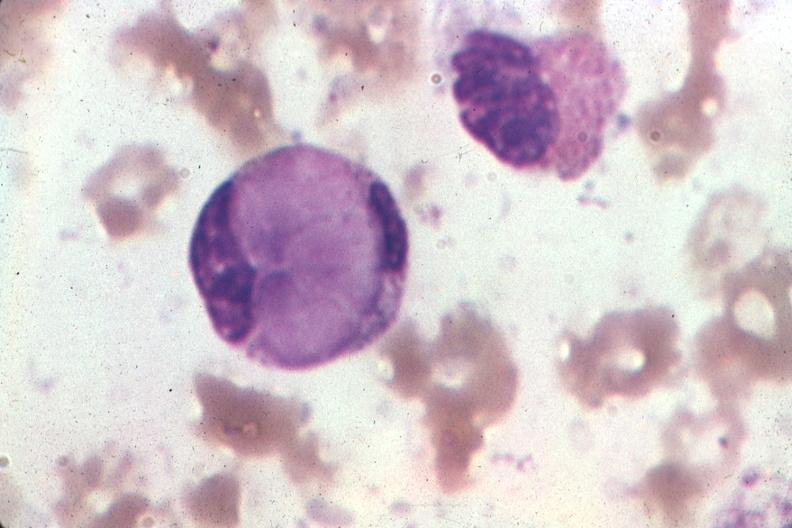what is present?
Answer the question using a single word or phrase. Bone marrow 